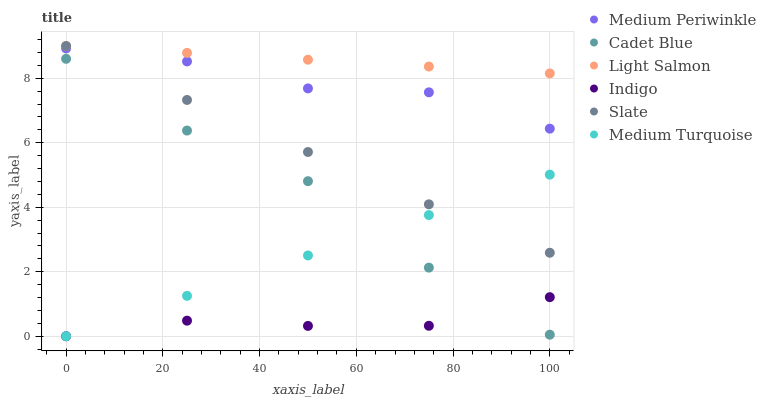Does Indigo have the minimum area under the curve?
Answer yes or no. Yes. Does Light Salmon have the maximum area under the curve?
Answer yes or no. Yes. Does Cadet Blue have the minimum area under the curve?
Answer yes or no. No. Does Cadet Blue have the maximum area under the curve?
Answer yes or no. No. Is Medium Turquoise the smoothest?
Answer yes or no. Yes. Is Cadet Blue the roughest?
Answer yes or no. Yes. Is Indigo the smoothest?
Answer yes or no. No. Is Indigo the roughest?
Answer yes or no. No. Does Indigo have the lowest value?
Answer yes or no. Yes. Does Cadet Blue have the lowest value?
Answer yes or no. No. Does Slate have the highest value?
Answer yes or no. Yes. Does Cadet Blue have the highest value?
Answer yes or no. No. Is Medium Turquoise less than Light Salmon?
Answer yes or no. Yes. Is Light Salmon greater than Medium Turquoise?
Answer yes or no. Yes. Does Medium Periwinkle intersect Slate?
Answer yes or no. Yes. Is Medium Periwinkle less than Slate?
Answer yes or no. No. Is Medium Periwinkle greater than Slate?
Answer yes or no. No. Does Medium Turquoise intersect Light Salmon?
Answer yes or no. No. 